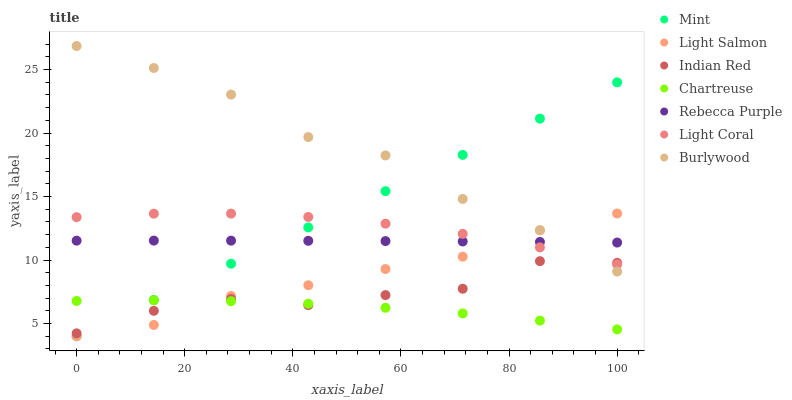Does Chartreuse have the minimum area under the curve?
Answer yes or no. Yes. Does Burlywood have the maximum area under the curve?
Answer yes or no. Yes. Does Light Coral have the minimum area under the curve?
Answer yes or no. No. Does Light Coral have the maximum area under the curve?
Answer yes or no. No. Is Mint the smoothest?
Answer yes or no. Yes. Is Indian Red the roughest?
Answer yes or no. Yes. Is Burlywood the smoothest?
Answer yes or no. No. Is Burlywood the roughest?
Answer yes or no. No. Does Light Salmon have the lowest value?
Answer yes or no. Yes. Does Burlywood have the lowest value?
Answer yes or no. No. Does Burlywood have the highest value?
Answer yes or no. Yes. Does Light Coral have the highest value?
Answer yes or no. No. Is Chartreuse less than Rebecca Purple?
Answer yes or no. Yes. Is Rebecca Purple greater than Indian Red?
Answer yes or no. Yes. Does Light Salmon intersect Mint?
Answer yes or no. Yes. Is Light Salmon less than Mint?
Answer yes or no. No. Is Light Salmon greater than Mint?
Answer yes or no. No. Does Chartreuse intersect Rebecca Purple?
Answer yes or no. No. 